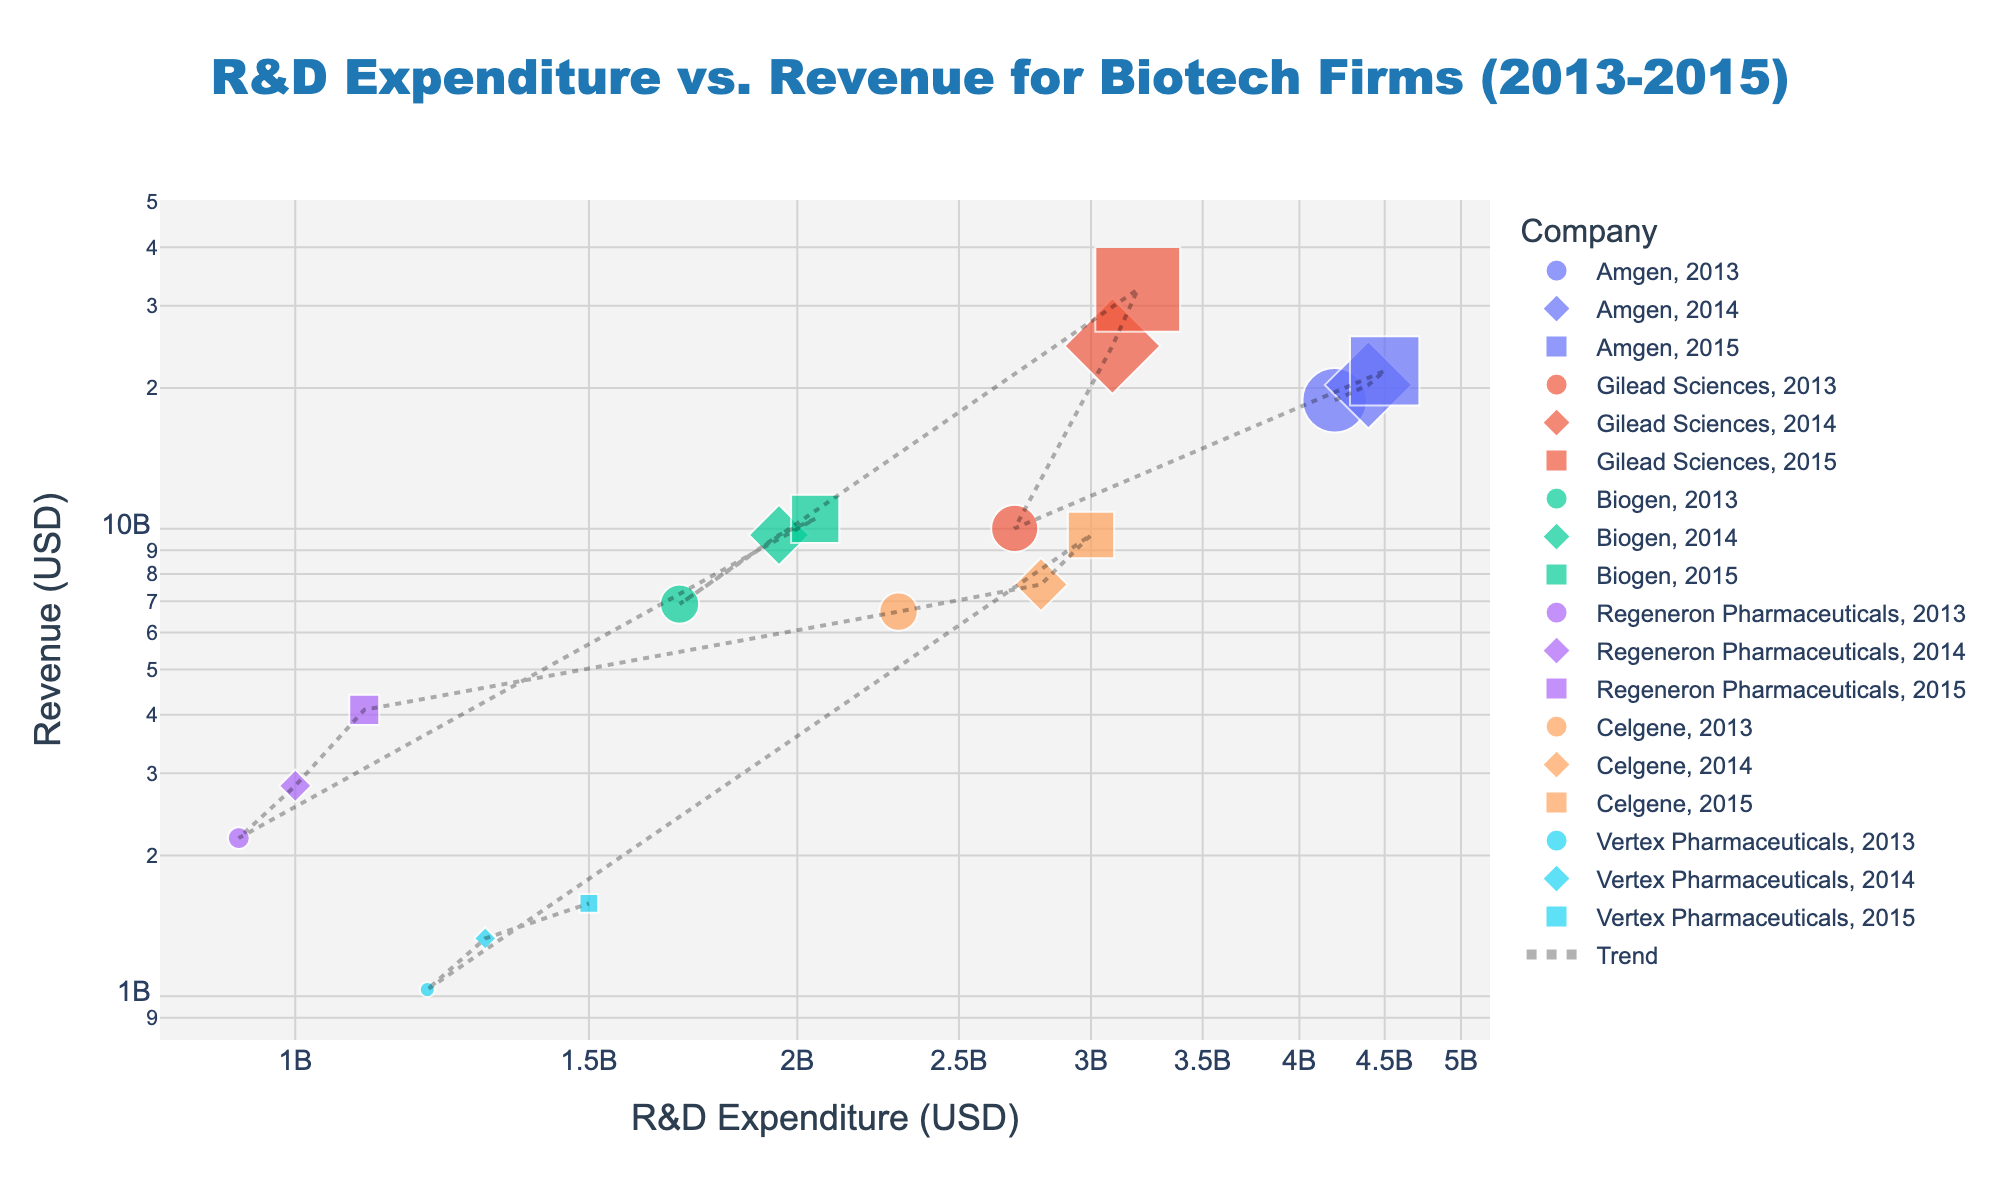What is the main title of the scatter plot? The main title of the scatter plot can be found at the top center of the figure. It summarizes the entire visualization.
Answer: "R&D Expenditure vs. Revenue for Biotech Firms (2013-2015)" Which company has the highest revenue in 2014, and what is the value? Look for the symbol representing the year 2014 and compare the revenue values on the y-axis among all companies for that year.
Answer: Gilead Sciences, $24,600,000,000 How does the R&D expenditure of Regeneron Pharmaceuticals in 2013 compare to that in 2015? Identify the symbols for Regeneron Pharmaceuticals in 2013 and 2015. Examine their positions on the x-axis to determine how the values differ.
Answer: Higher in 2015 Which company had the lowest R&D expenditure in 2013, and what was the amount? Focus on the symbols from 2013 and identify the company with the leftmost position on the x-axis.
Answer: Regeneron Pharmaceuticals, $925,000,000 For Amgen, how does the trend in revenue from 2013 to 2015 compare to the trend in R&D expenditure? Trace the points for Amgen from 2013 to 2015 and observe the direction and steepness of changes in both revenue and R&D expenditure.
Answer: Both show an increasing trend What is the approximate log-scale ratio of the highest to the lowest R&D expenditure across all firms and years? Calculate the ratio in the log scale for the highest and lowest R&D expenditures by finding the log differences on the x-axis. The highest is Amgen in 2014 and 2015 (~ $4.5 billion), and the lowest is Regeneron Pharmaceuticals in 2013 (~ $925 million).
Answer: ~0.7 (log scale ratio) Which year symbol looks the most distinct, and why might this be the case? Observe all the symbols and identify which one stands out due to its shape, size, or any noticeable characteristic.
Answer: 2014 (different colored symbol) Do companies with higher R&D expenditures generally have higher revenues? Examine the overall distribution of points and determine if there is a visible trend showing higher revenues with higher R&D expenditures.
Answer: Yes How does the size of the symbols correlate with revenues in the scatter plot? Check if there is a pattern between the symbol size and their corresponding revenue values on the y-axis.
Answer: Larger symbols represent higher revenues Which company's revenue increased the most between any two consecutive years, and what was the increase amount? Compare the revenue values for each company between consecutive years and identify the maximum increase.
Answer: Gilead Sciences, from 2013 to 2014, $14,580,000,000 